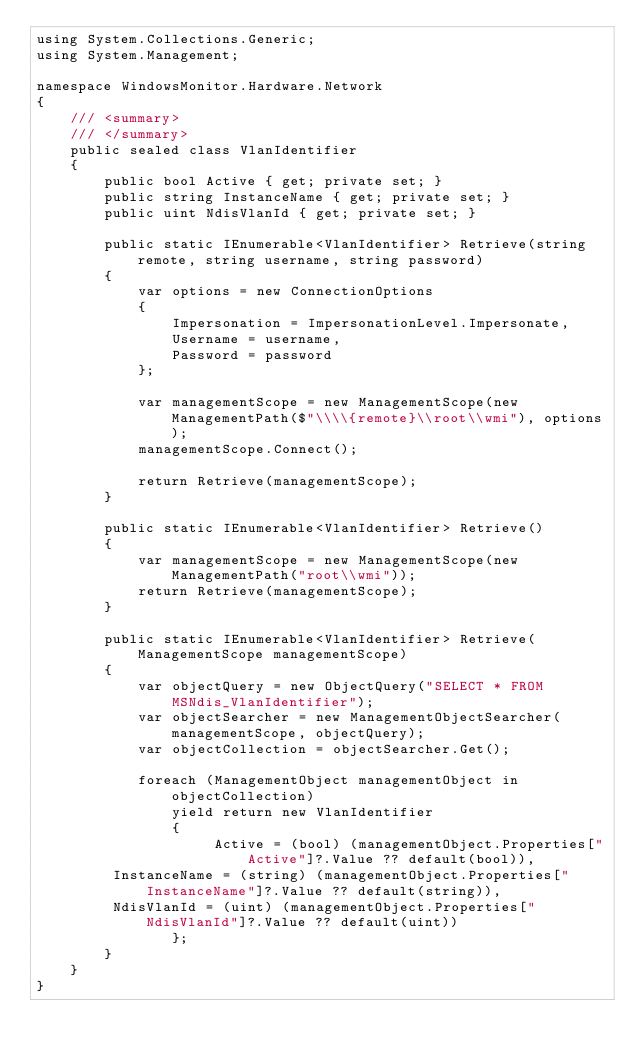<code> <loc_0><loc_0><loc_500><loc_500><_C#_>using System.Collections.Generic;
using System.Management;

namespace WindowsMonitor.Hardware.Network
{
    /// <summary>
    /// </summary>
    public sealed class VlanIdentifier
    {
		public bool Active { get; private set; }
		public string InstanceName { get; private set; }
		public uint NdisVlanId { get; private set; }

        public static IEnumerable<VlanIdentifier> Retrieve(string remote, string username, string password)
        {
            var options = new ConnectionOptions
            {
                Impersonation = ImpersonationLevel.Impersonate,
                Username = username,
                Password = password
            };

            var managementScope = new ManagementScope(new ManagementPath($"\\\\{remote}\\root\\wmi"), options);
            managementScope.Connect();

            return Retrieve(managementScope);
        }

        public static IEnumerable<VlanIdentifier> Retrieve()
        {
            var managementScope = new ManagementScope(new ManagementPath("root\\wmi"));
            return Retrieve(managementScope);
        }

        public static IEnumerable<VlanIdentifier> Retrieve(ManagementScope managementScope)
        {
            var objectQuery = new ObjectQuery("SELECT * FROM MSNdis_VlanIdentifier");
            var objectSearcher = new ManagementObjectSearcher(managementScope, objectQuery);
            var objectCollection = objectSearcher.Get();

            foreach (ManagementObject managementObject in objectCollection)
                yield return new VlanIdentifier
                {
                     Active = (bool) (managementObject.Properties["Active"]?.Value ?? default(bool)),
		 InstanceName = (string) (managementObject.Properties["InstanceName"]?.Value ?? default(string)),
		 NdisVlanId = (uint) (managementObject.Properties["NdisVlanId"]?.Value ?? default(uint))
                };
        }
    }
}</code> 